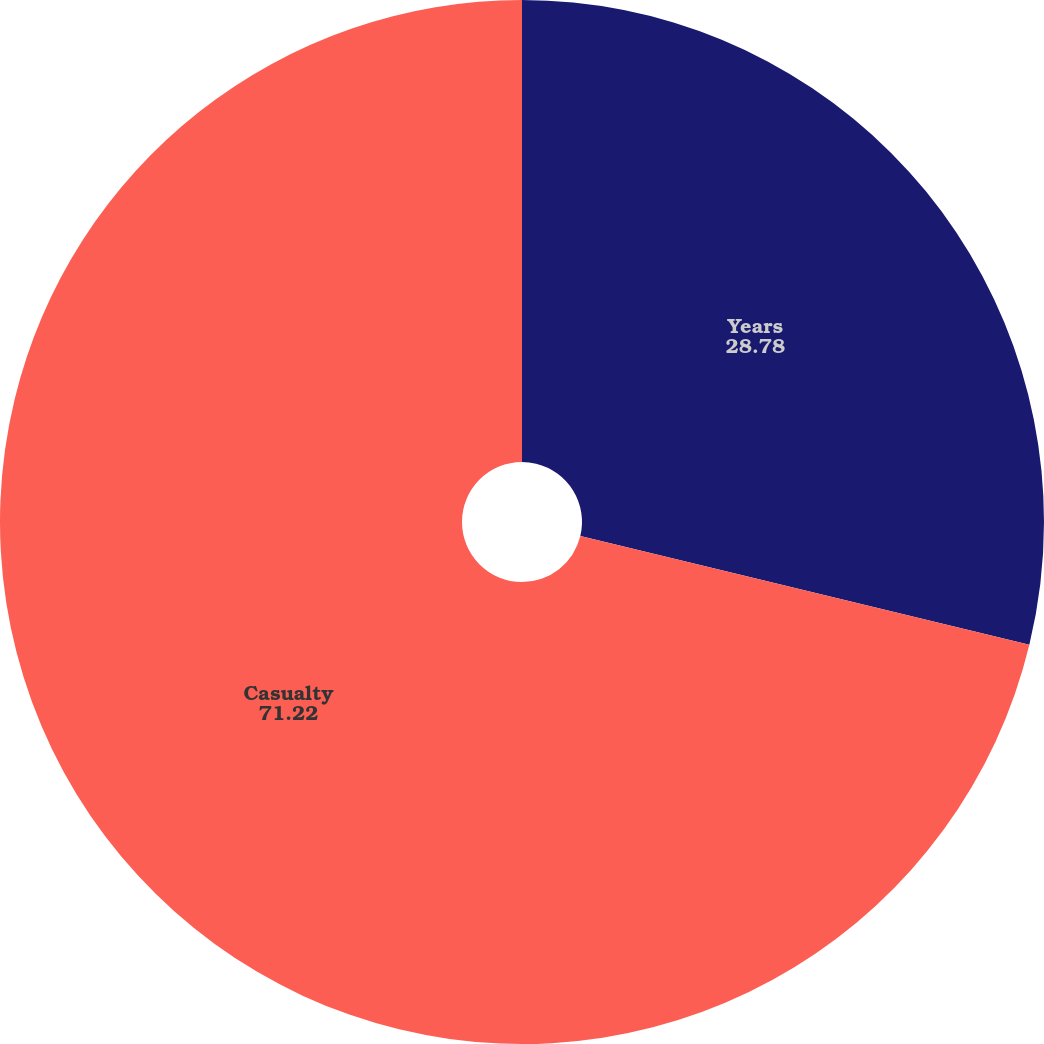Convert chart to OTSL. <chart><loc_0><loc_0><loc_500><loc_500><pie_chart><fcel>Years<fcel>Casualty<nl><fcel>28.78%<fcel>71.22%<nl></chart> 